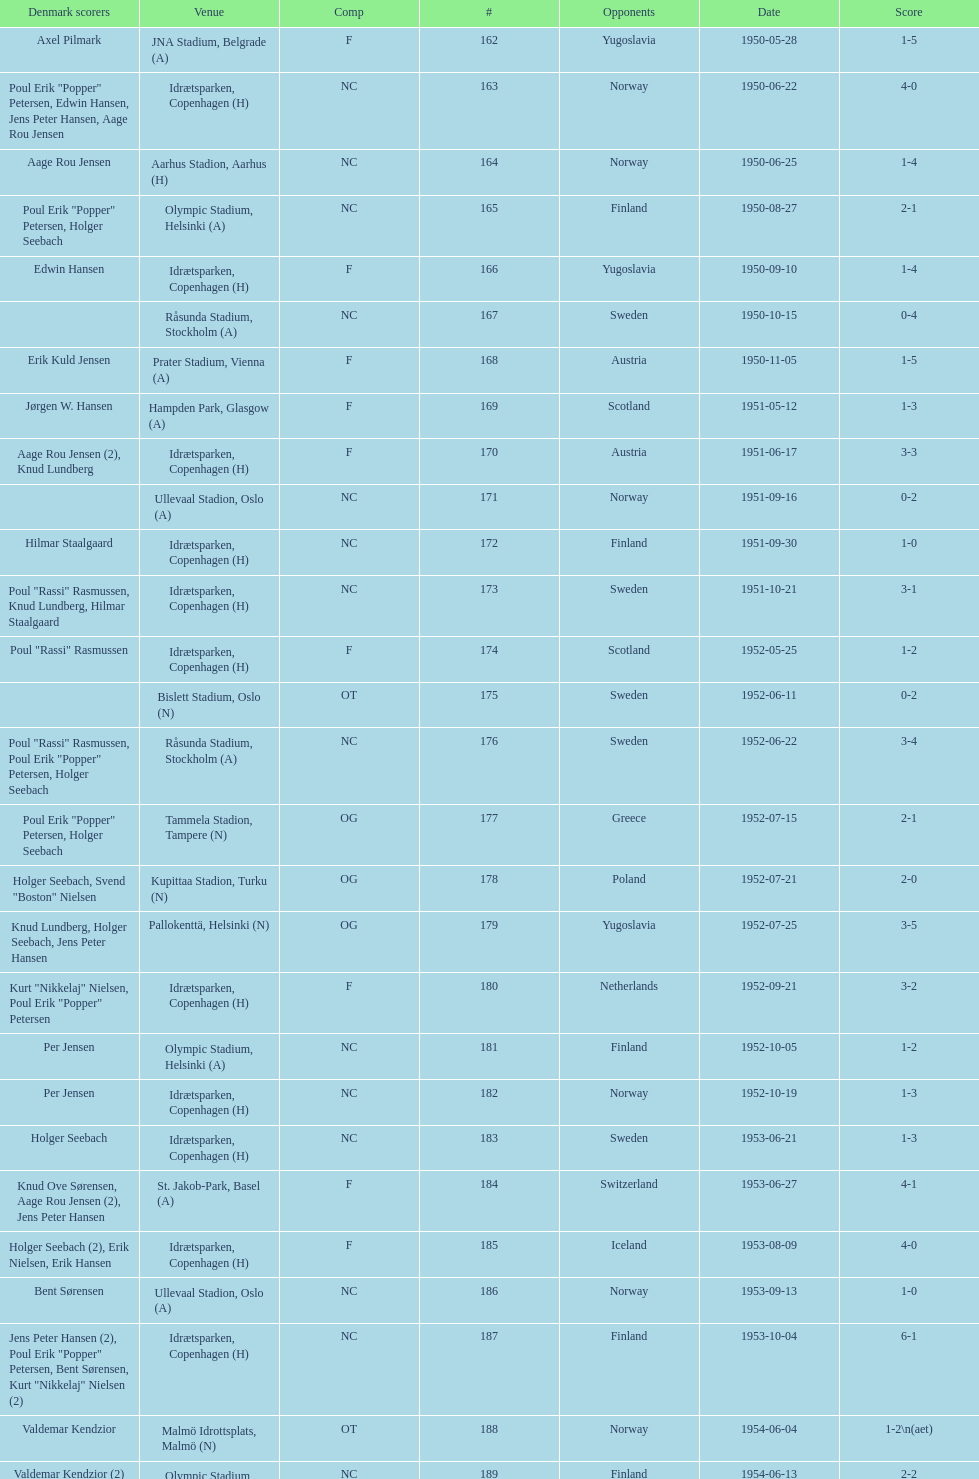Who did they play in the game listed directly above july 25, 1952? Poland. 